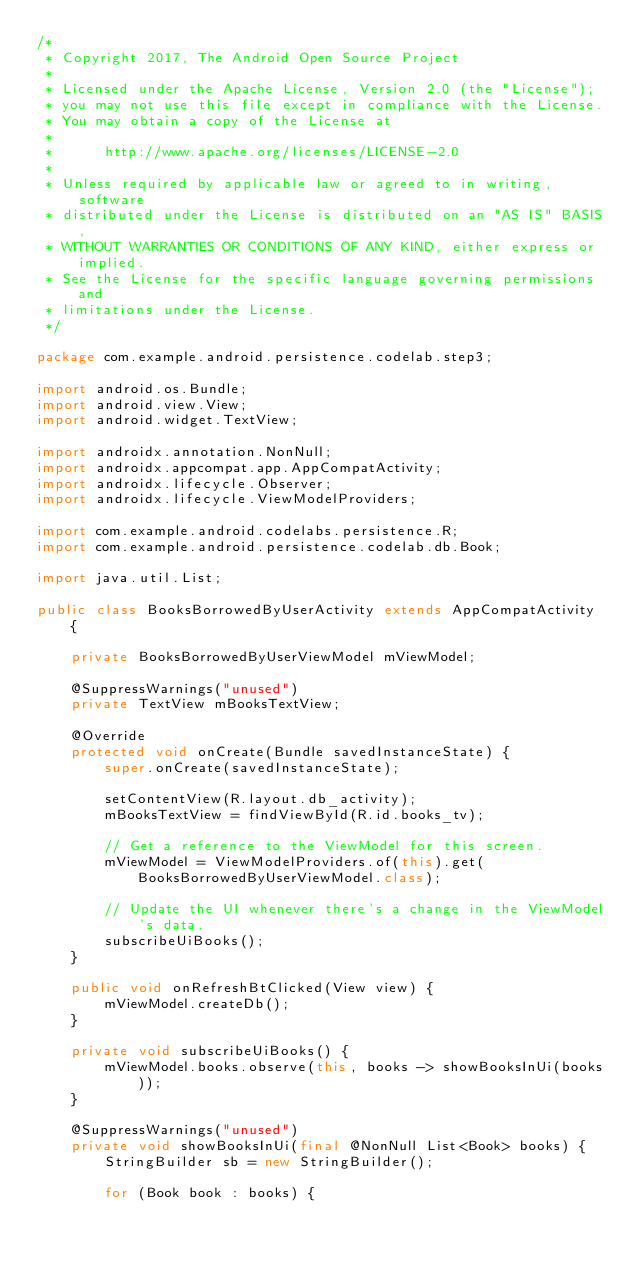Convert code to text. <code><loc_0><loc_0><loc_500><loc_500><_Java_>/*
 * Copyright 2017, The Android Open Source Project
 *
 * Licensed under the Apache License, Version 2.0 (the "License");
 * you may not use this file except in compliance with the License.
 * You may obtain a copy of the License at
 *
 *      http://www.apache.org/licenses/LICENSE-2.0
 *
 * Unless required by applicable law or agreed to in writing, software
 * distributed under the License is distributed on an "AS IS" BASIS,
 * WITHOUT WARRANTIES OR CONDITIONS OF ANY KIND, either express or implied.
 * See the License for the specific language governing permissions and
 * limitations under the License.
 */

package com.example.android.persistence.codelab.step3;

import android.os.Bundle;
import android.view.View;
import android.widget.TextView;

import androidx.annotation.NonNull;
import androidx.appcompat.app.AppCompatActivity;
import androidx.lifecycle.Observer;
import androidx.lifecycle.ViewModelProviders;

import com.example.android.codelabs.persistence.R;
import com.example.android.persistence.codelab.db.Book;

import java.util.List;

public class BooksBorrowedByUserActivity extends AppCompatActivity {

    private BooksBorrowedByUserViewModel mViewModel;

    @SuppressWarnings("unused")
    private TextView mBooksTextView;

    @Override
    protected void onCreate(Bundle savedInstanceState) {
        super.onCreate(savedInstanceState);

        setContentView(R.layout.db_activity);
        mBooksTextView = findViewById(R.id.books_tv);

        // Get a reference to the ViewModel for this screen.
        mViewModel = ViewModelProviders.of(this).get(BooksBorrowedByUserViewModel.class);

        // Update the UI whenever there's a change in the ViewModel's data.
        subscribeUiBooks();
    }

    public void onRefreshBtClicked(View view) {
        mViewModel.createDb();
    }

    private void subscribeUiBooks() {
        mViewModel.books.observe(this, books -> showBooksInUi(books));
    }

    @SuppressWarnings("unused")
    private void showBooksInUi(final @NonNull List<Book> books) {
        StringBuilder sb = new StringBuilder();

        for (Book book : books) {</code> 